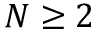<formula> <loc_0><loc_0><loc_500><loc_500>N \geq 2</formula> 